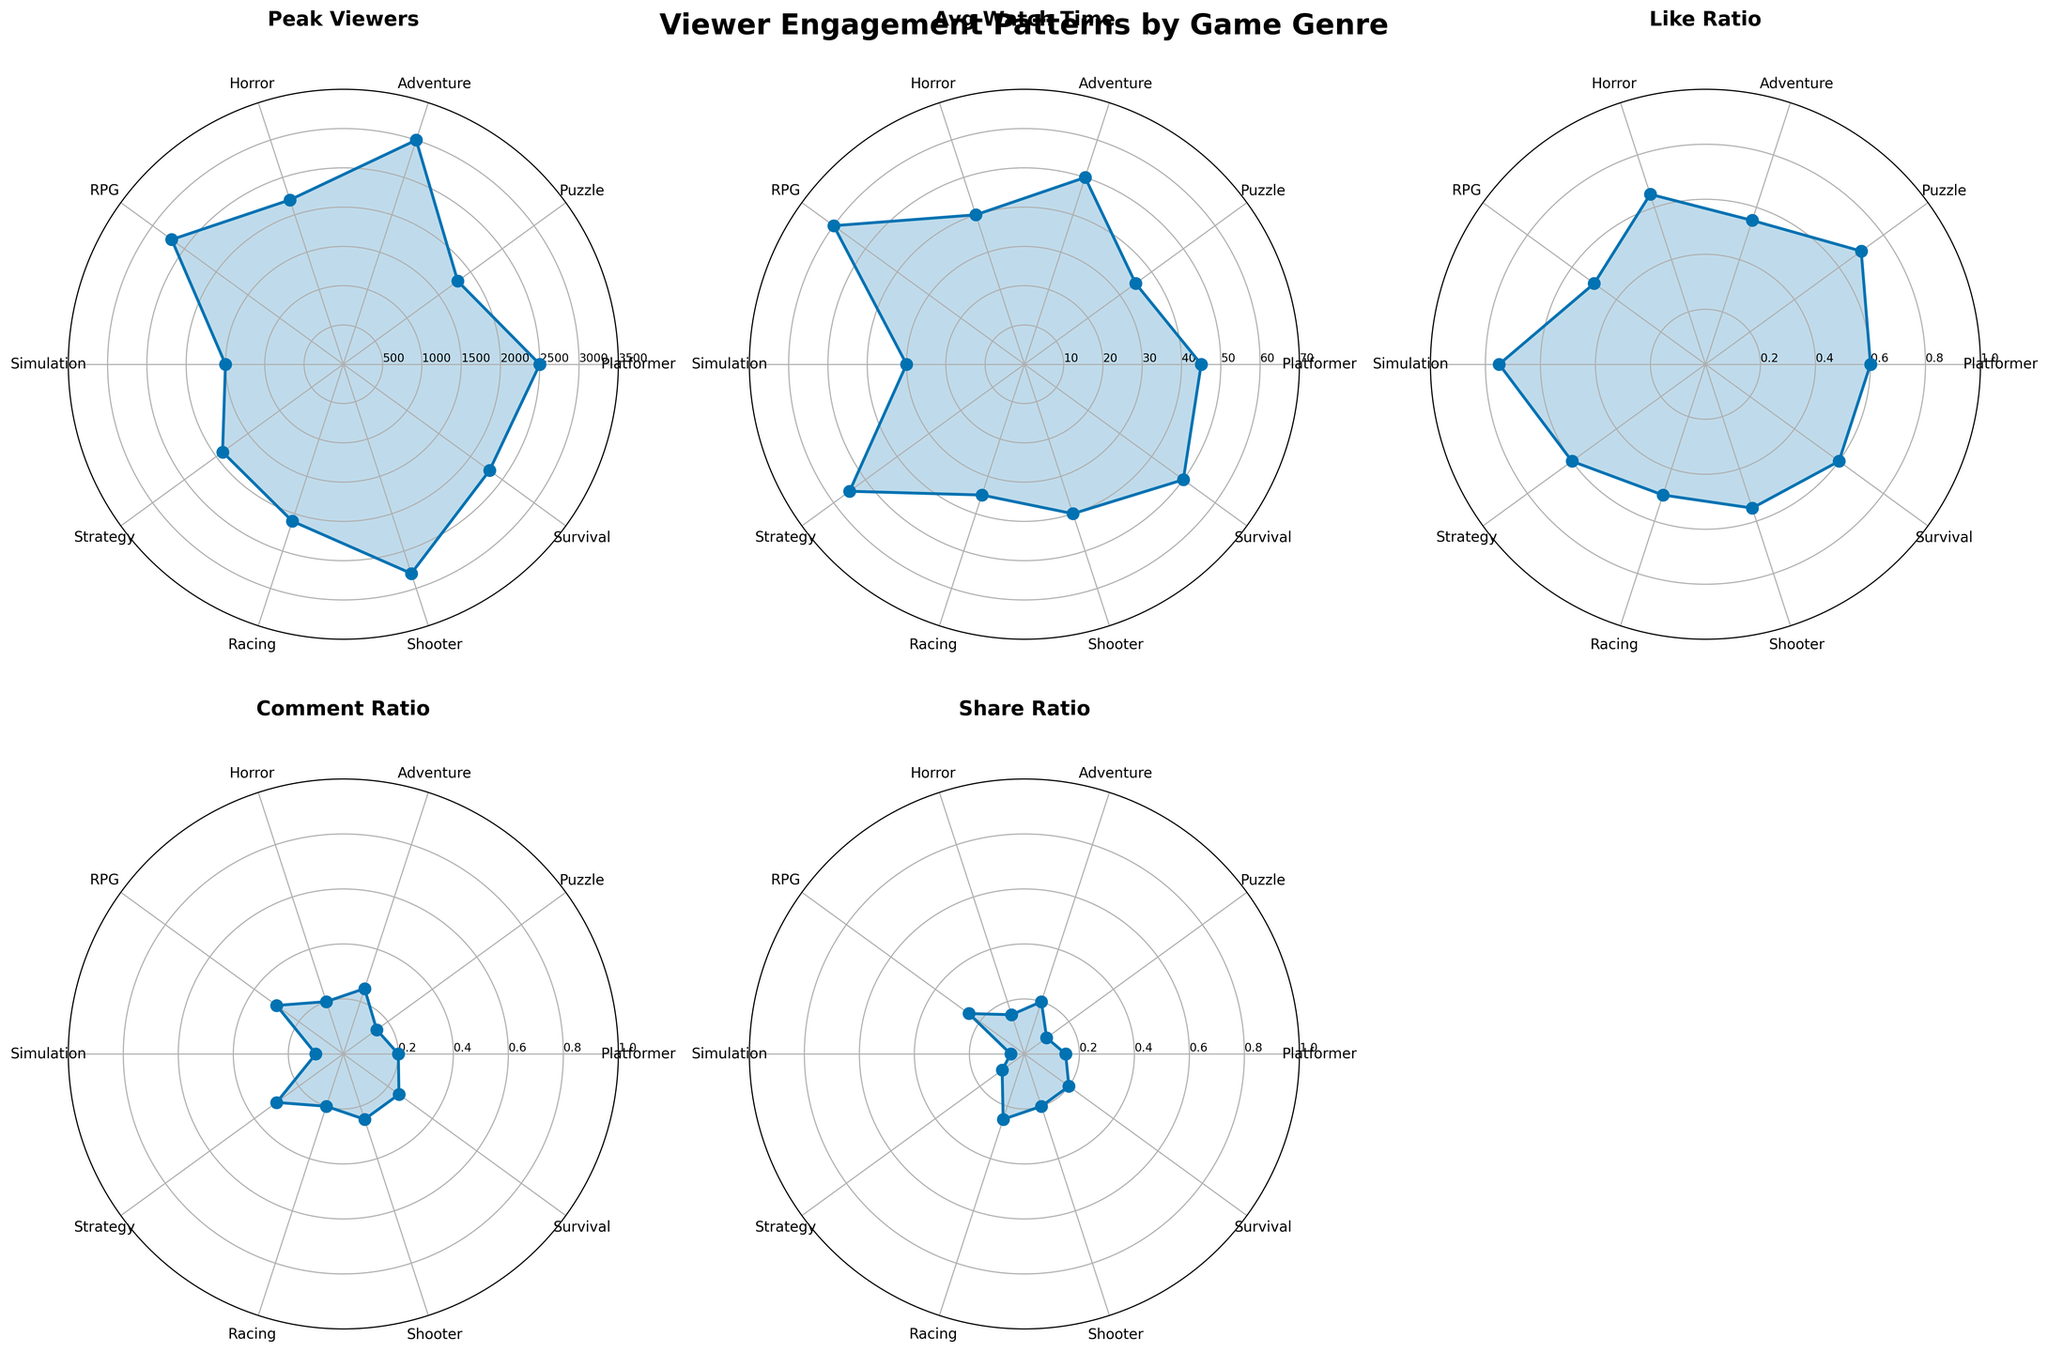What is the title of the figure? The title of the figure is found at the top center of the plot. It provides an overview of what the plot represents. In this case, the title is "Viewer Engagement Patterns by Game Genre".
Answer: Viewer Engagement Patterns by Game Genre Which genre has the highest peak viewers? To determine this, look at the "Peak Viewers" subplot. The genre with the line reaching the highest value on the radial axis is the one with the highest peak viewers. Here, the Adventure genre reaches the highest peak viewers at 3000.
Answer: Adventure Which genre has the lowest average watch time? Look at the "Avg Watch Time" subplot. The genre whose line reaches the lowest value on the radial axis is the one with the lowest average watch time. In this case, the Simulation genre has the lowest average watch time at 30 minutes.
Answer: Simulation What is the difference in comment ratio between RPG and Simulation genres? To find out, look at the "Comment Ratio" subplot. Locate the lines for RPG (0.3) and Simulation (0.1). Subtract the Simulation's comment ratio from the RPG's comment ratio: 0.3 - 0.1 = 0.2.
Answer: 0.2 Which genre has the highest share ratio, and what is its value? Check the "Share Ratio" subplot. The genre whose line reaches the highest value on the radial axis has the highest share ratio. Here, RPG reaches the highest share ratio at 0.25.
Answer: RPG, 0.25 How do the like ratios of Platformer and Puzzle genres compare? Refer to the "Like Ratio" subplot. The Platformer genre has a like ratio of 0.6, while the Puzzle genre has a like ratio of 0.7. The Puzzle genre has a higher like ratio compared to the Platformer genre.
Answer: Puzzle has a higher like ratio Which genre has a peak viewer count closest to 2500? In the "Peak Viewers" subplot, identify the genre whose peak viewers are closest to 2500. The Platformer genre has a peak viewer count exactly at 2500.
Answer: Platformer What is the average watch time for the top 3 genres by peak viewers? First, identify the genres with the highest peak viewers from the "Peak Viewers" subplot: Adventure (3000), Shooter (2800), and RPG (2700). Then, check their average watch times: Adventure (50 min), Shooter (40 min), and RPG (60 min). Calculate the average of these times: (50 + 40 + 60) / 3 = 50 minutes.
Answer: 50 minutes Which genre has the highest proportion of like ratio to comment ratio? Check the "Like Ratio" and "Comment Ratio" subplots. Calculate the proportion for each genre by dividing their like ratio by their comment ratio. Simulation has the highest like to comment ratio with like ratio 0.75 and comment ratio 0.1, giving a proportion of 0.75 / 0.1 = 7.5.
Answer: Simulation Is there any genre with an average watch time and share ratio both greater than 40 and 0.2, respectively? Checking the "Avg Watch Time" and "Share Ratio" subplots, RPG is the only genre with avg watch time (60) > 40 and share ratio (0.25) > 0.2.
Answer: Yes, RPG 